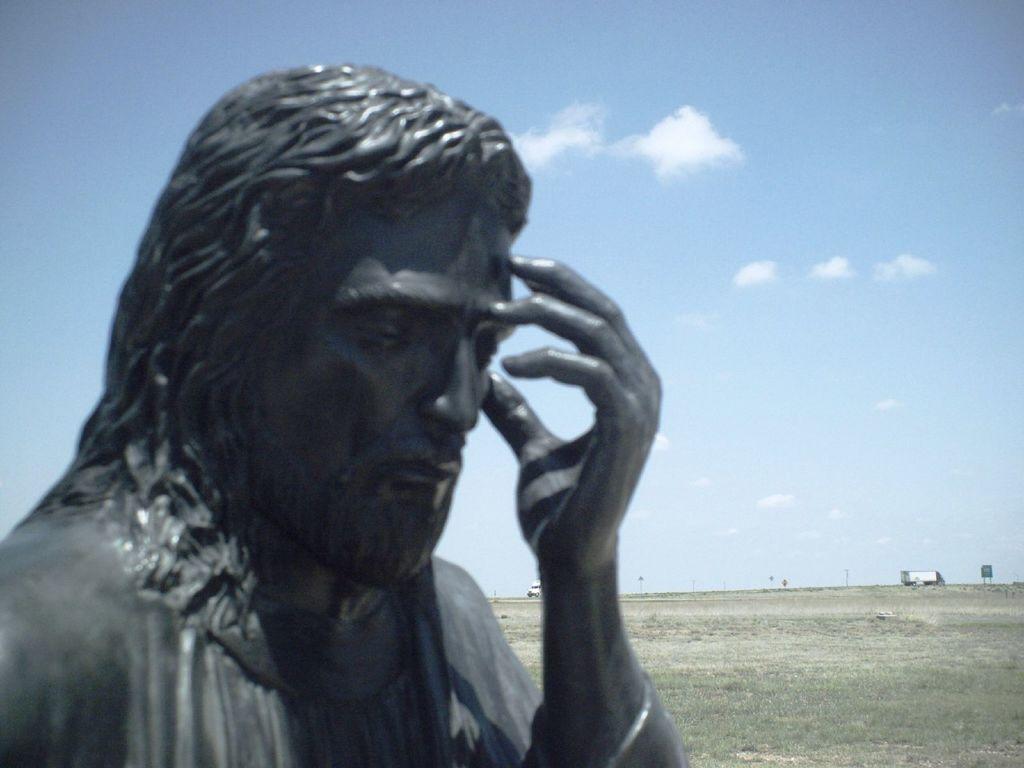Can you describe this image briefly? On the left side, there is a statue of a person, keeping fingers of a hand on his head. In the background, there are vehicles, there is a sign board, there is grass on the ground and there are clouds in the blue sky. 